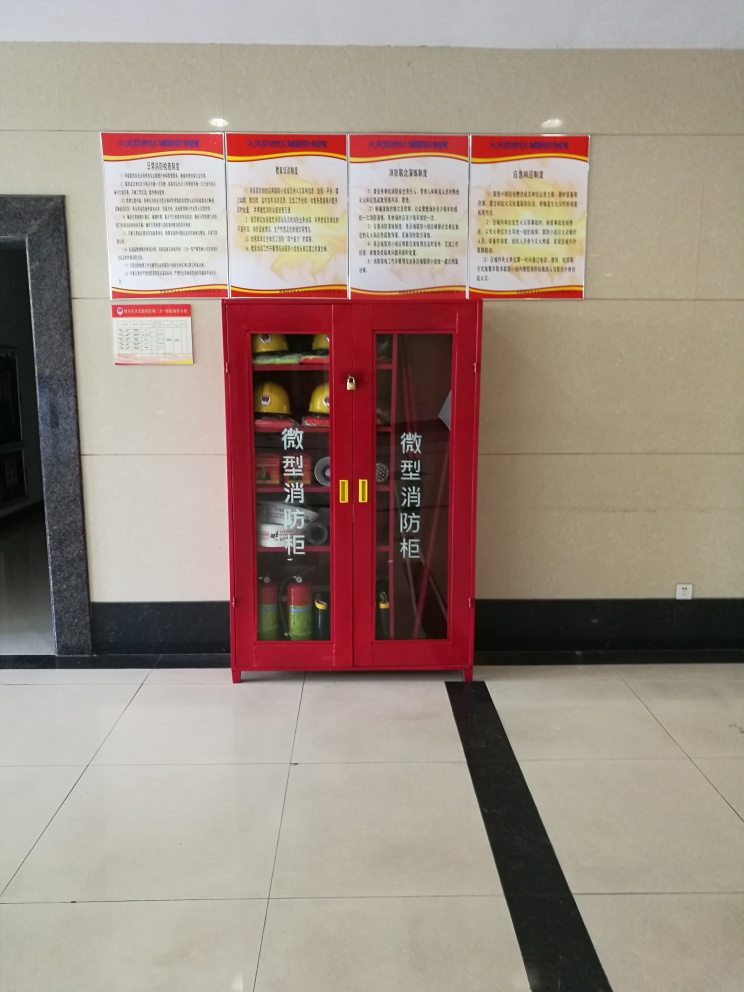This looks like a public setting; why is fire safety important here? Fire safety is particularly important in public settings as it concerns the well-being of a larger number of people. Proper fire safety measures, including equipment and clear instructions, can prevent disasters, limit damage, and ensure that individuals can evacuate safely and quickly in case of a fire. 